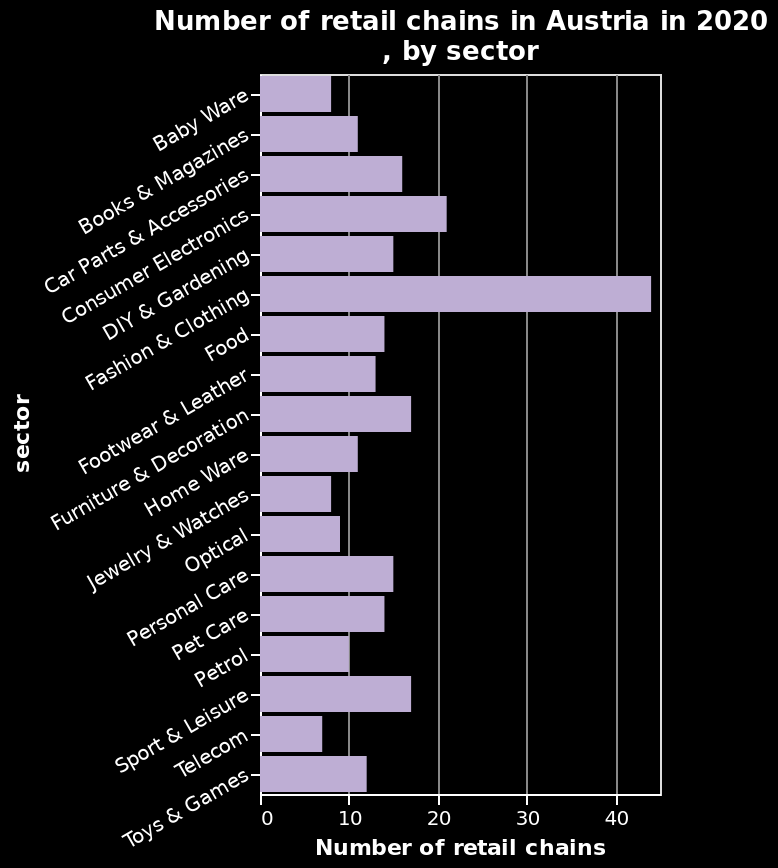<image>
What does the bar plot reveal about the retail chains in Austria in 2020? The bar plot reveals the distribution and variation in the number of retail chains across different sectors in Austria during the year 2020. What does the bar plot depict? The bar plot depicts the "Number of retail chains in Austria in 2020, by sector." 